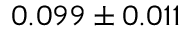<formula> <loc_0><loc_0><loc_500><loc_500>0 . 0 9 9 \pm 0 . 0 1 1</formula> 